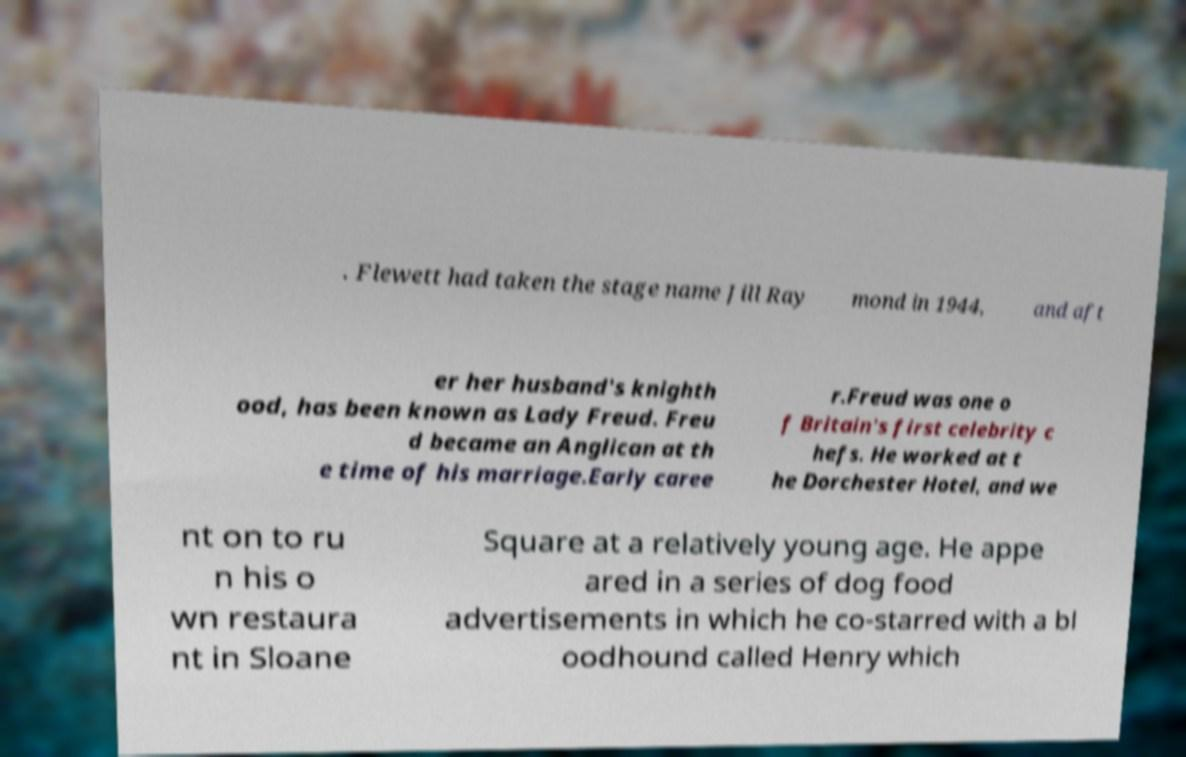Could you extract and type out the text from this image? . Flewett had taken the stage name Jill Ray mond in 1944, and aft er her husband's knighth ood, has been known as Lady Freud. Freu d became an Anglican at th e time of his marriage.Early caree r.Freud was one o f Britain's first celebrity c hefs. He worked at t he Dorchester Hotel, and we nt on to ru n his o wn restaura nt in Sloane Square at a relatively young age. He appe ared in a series of dog food advertisements in which he co-starred with a bl oodhound called Henry which 